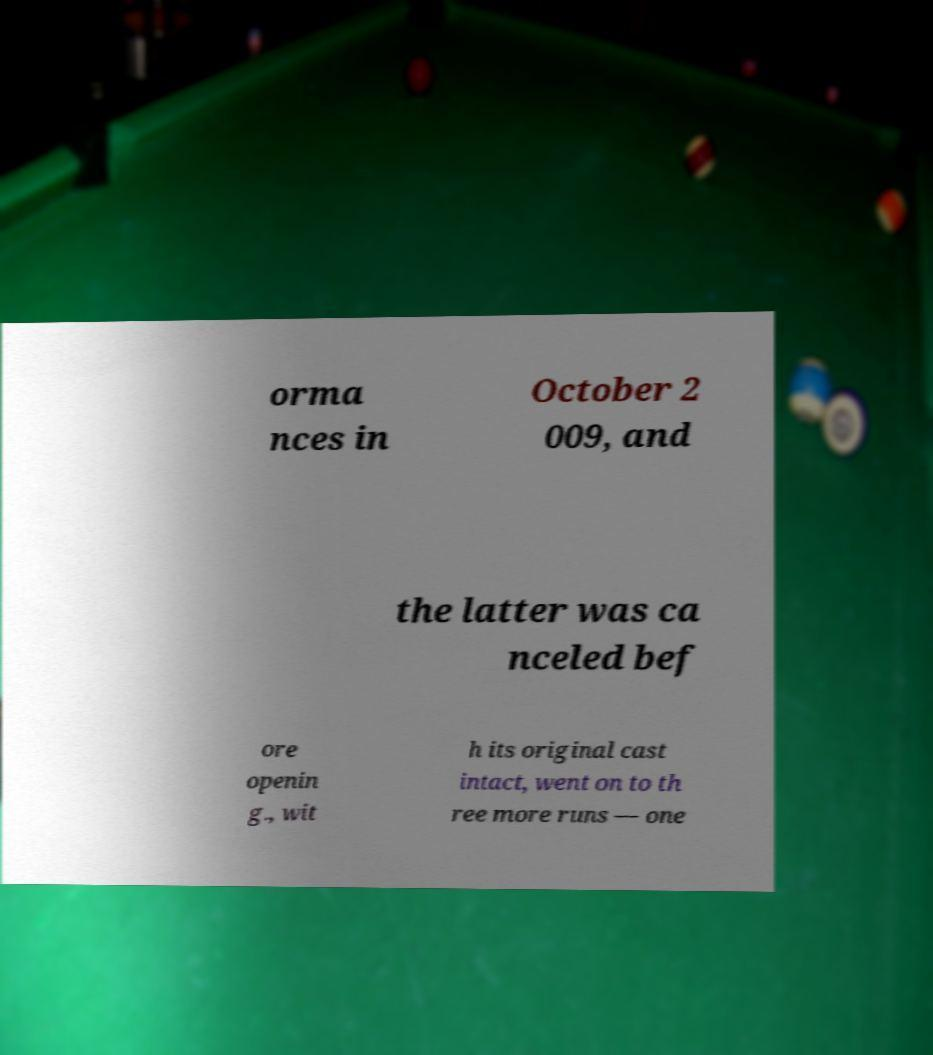Please read and relay the text visible in this image. What does it say? orma nces in October 2 009, and the latter was ca nceled bef ore openin g., wit h its original cast intact, went on to th ree more runs — one 